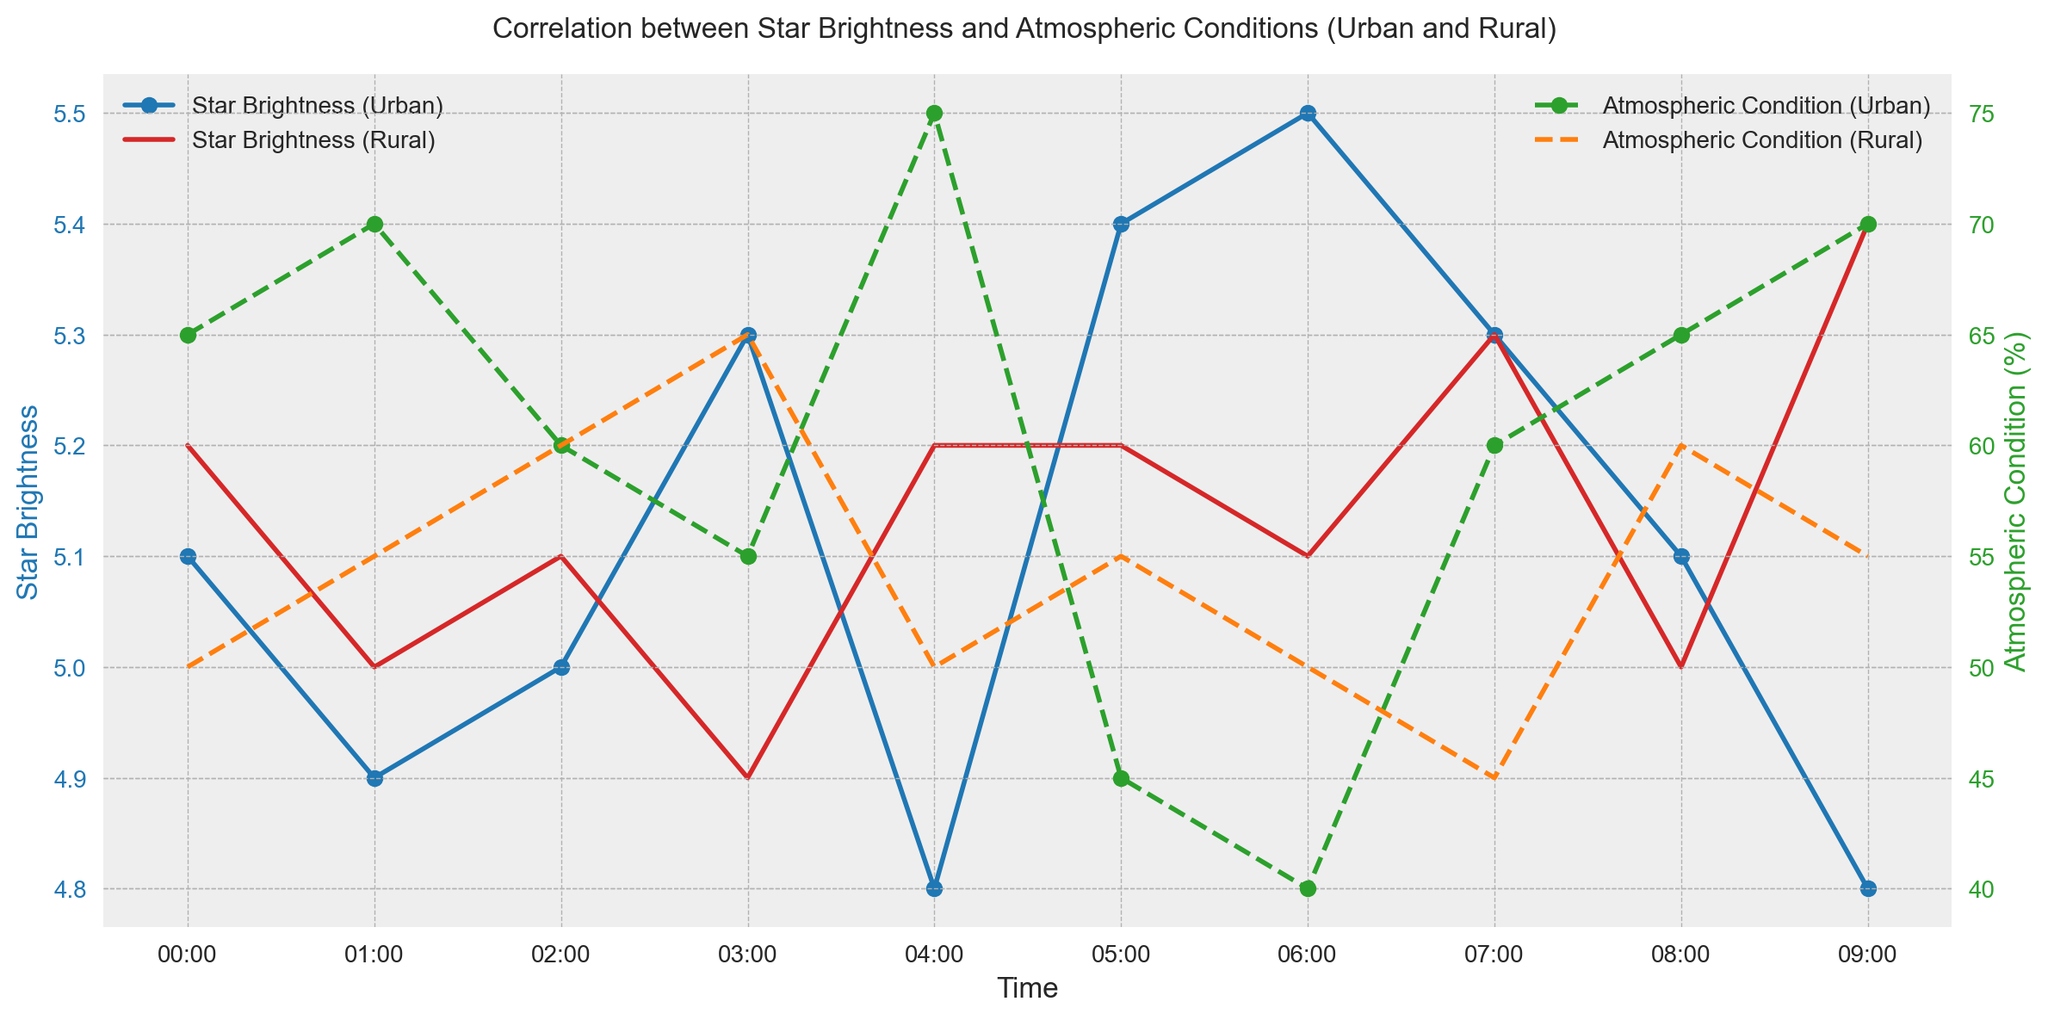Which location has the higher peak in star brightness? The highest star brightness for both urban and rural locations is seen by looking at the highest points on the star brightness curves for each location. The peak for Urban is at 5.5 and for Rural is at 5.4.
Answer: Urban Are the atmospheric conditions generally better in urban or rural areas? By visually comparing the atmospheric condition lines, it is clear that the rural locations tend to have consistently lower (better) atmospheric condition percentages compared to the urban areas.
Answer: Rural At what time do urban areas see the lowest star brightness? In the urban plot, the lowest point on the star brightness line corresponds to the time. The lowest star brightness for urban areas occurs at 04:00 (4.8).
Answer: 04:00 How does the relationship between star brightness and atmospheric conditions differ between urban and rural areas? Analyze the trends in both the urban and rural star brightness and atmospheric condition lines. In urban areas, star brightness often inversely correlates with atmospheric conditions, while in rural areas the correlation is less direct, showing more consistent brightness irrespective of atmospheric conditions.
Answer: Urban: Inversely correlated, Rural: Less direct correlation What's the average star brightness in rural areas over the given time period? The star brightness in rural areas at different times is: 5.2, 5.0, 5.1, 4.9, 5.2, 5.2, 5.1, 5.3, 5.0, 5.4. Summing them yields 51.6 and dividing by 10 time points gives an average of 5.16.
Answer: 5.16 Which location shows a more significant fluctuation in atmospheric conditions over time? By looking at the range of atmospheric condition values for both locations, the urban atmospheric condition fluctuates from 40 to 75, while rural conditions range from 45 to 65, indicating urban areas have more significant fluctuation.
Answer: Urban Do the times of peak atmospheric conditions correspond to times of low star brightness in urban areas? Checking the urban plot, peak atmospheric conditions (~75) occur at 04:00, where the star brightness is also at its lowest (4.8).
Answer: Yes What is the difference in star brightness between rural and urban areas at 06:00? The star brightness in rural areas at 06:00 is 5.1, and in urban areas is 5.5. The difference is 5.5 - 5.1 = 0.4.
Answer: 0.4 How do rural and urban atmospheric conditions compare at 07:00? At 07:00, urban atmospheric conditions are at 60%, and rural atmospheric conditions are at 45%. Therefore, urban conditions are higher.
Answer: Urban: 60%, Rural: 45% Is the overall trend in star brightness rising or falling in rural areas from 00:00 to 09:00? By examining the trend in the rural star brightness line from 00:00 to 09:00, it is clear that it slightly rises as it starts at 5.2 and ends at 5.4.
Answer: Rising 